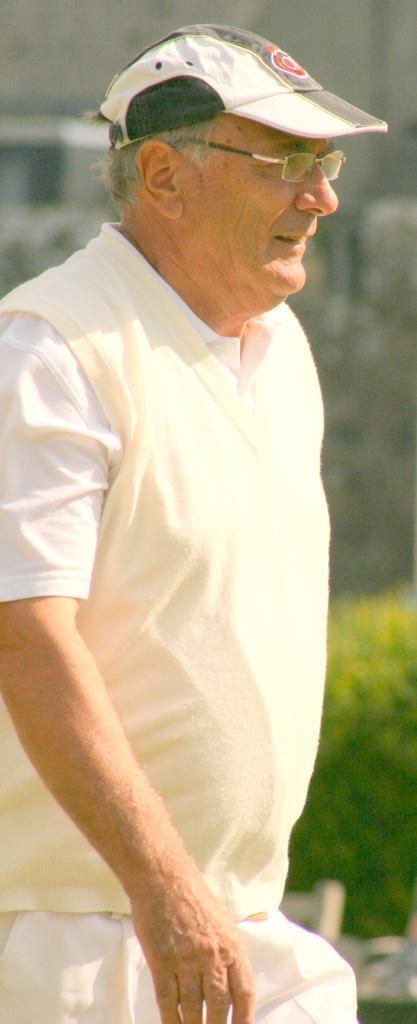Could you give a brief overview of what you see in this image? In this image, we can see an old man, he is wearing a hat and specs, in the background there is a green color plant. 